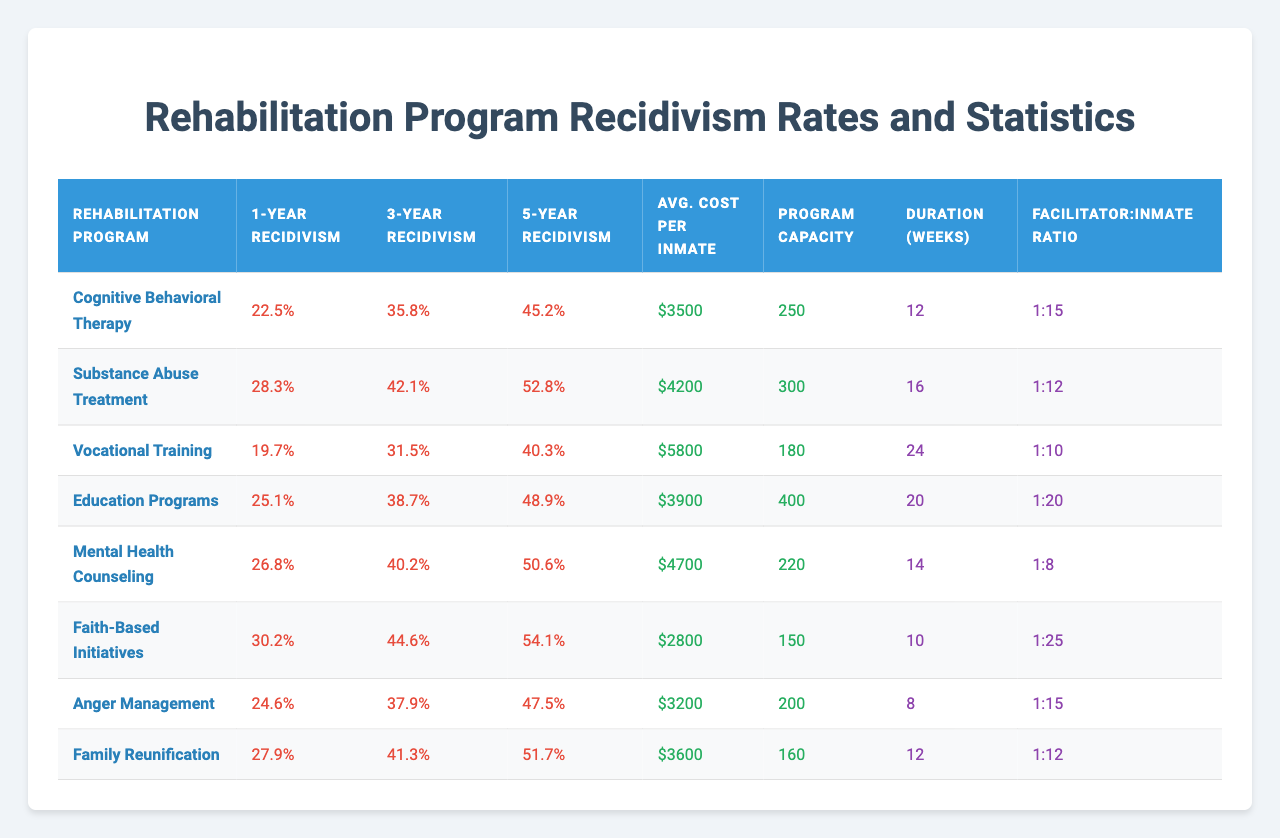What is the 1-year recidivism rate for Vocational Training? According to the table, the 1-year recidivism rate for Vocational Training is listed under that program, which shows a value of 19.7%.
Answer: 19.7% Which rehabilitation program has the highest 5-year recidivism rate? The table shows that Faith-Based Initiatives has the highest 5-year recidivism rate at 54.1%.
Answer: Faith-Based Initiatives What is the average program cost per inmate for Education Programs? The average program cost per inmate for Education Programs is found directly in the table, which indicates it is $3,900.
Answer: $3900 Is the facilitator to inmate ratio for Mental Health Counseling better than that for Anger Management? The table shows the ratio for Mental Health Counseling is 1:8 and for Anger Management is 1:15. Since 1:8 indicates fewer inmates per facilitator, it is indeed better.
Answer: Yes What is the difference in the 3-year recidivism rate between Substance Abuse Treatment and Vocational Training? The 3-year recidivism rate for Substance Abuse Treatment is 42.1% and for Vocational Training is 31.5%. Calculating the difference: 42.1% - 31.5% = 10.6%.
Answer: 10.6% What is the average 1-year recidivism rate across all programs? To find the average, we sum the 1-year recidivism rates: (22.5 + 28.3 + 19.7 + 25.1 + 26.8 + 30.2 + 24.6 + 27.9) = 205.1%. There are 8 programs, so the average is 205.1% / 8 = 25.64%.
Answer: 25.64% Which program has a lower 5-year recidivism rate: Family Reunification or Cognitive Behavioral Therapy? The table indicates that Family Reunification has a 5-year recidivism rate of 51.7%, while Cognitive Behavioral Therapy has a rate of 45.2%. Since 45.2% is lower than 51.7%, Cognitive Behavioral Therapy is the better option.
Answer: Cognitive Behavioral Therapy How many more inmates can be accommodated in Education Programs than in Substance Abuse Treatment? The capacity for Education Programs is 400, while for Substance Abuse Treatment it is 300. To find the difference, subtract: 400 - 300 = 100.
Answer: 100 What is the overall capacity of all rehabilitation programs combined? To find the overall capacity, sum the individual capacities: 250 + 300 + 180 + 400 + 220 + 150 + 200 + 160 = 1860.
Answer: 1860 Is Mental Health Counseling more expensive than Vocational Training? The average cost per inmate for Mental Health Counseling is $4,700, while for Vocational Training it is $5,800. So, Mental Health Counseling is less expensive.
Answer: No 